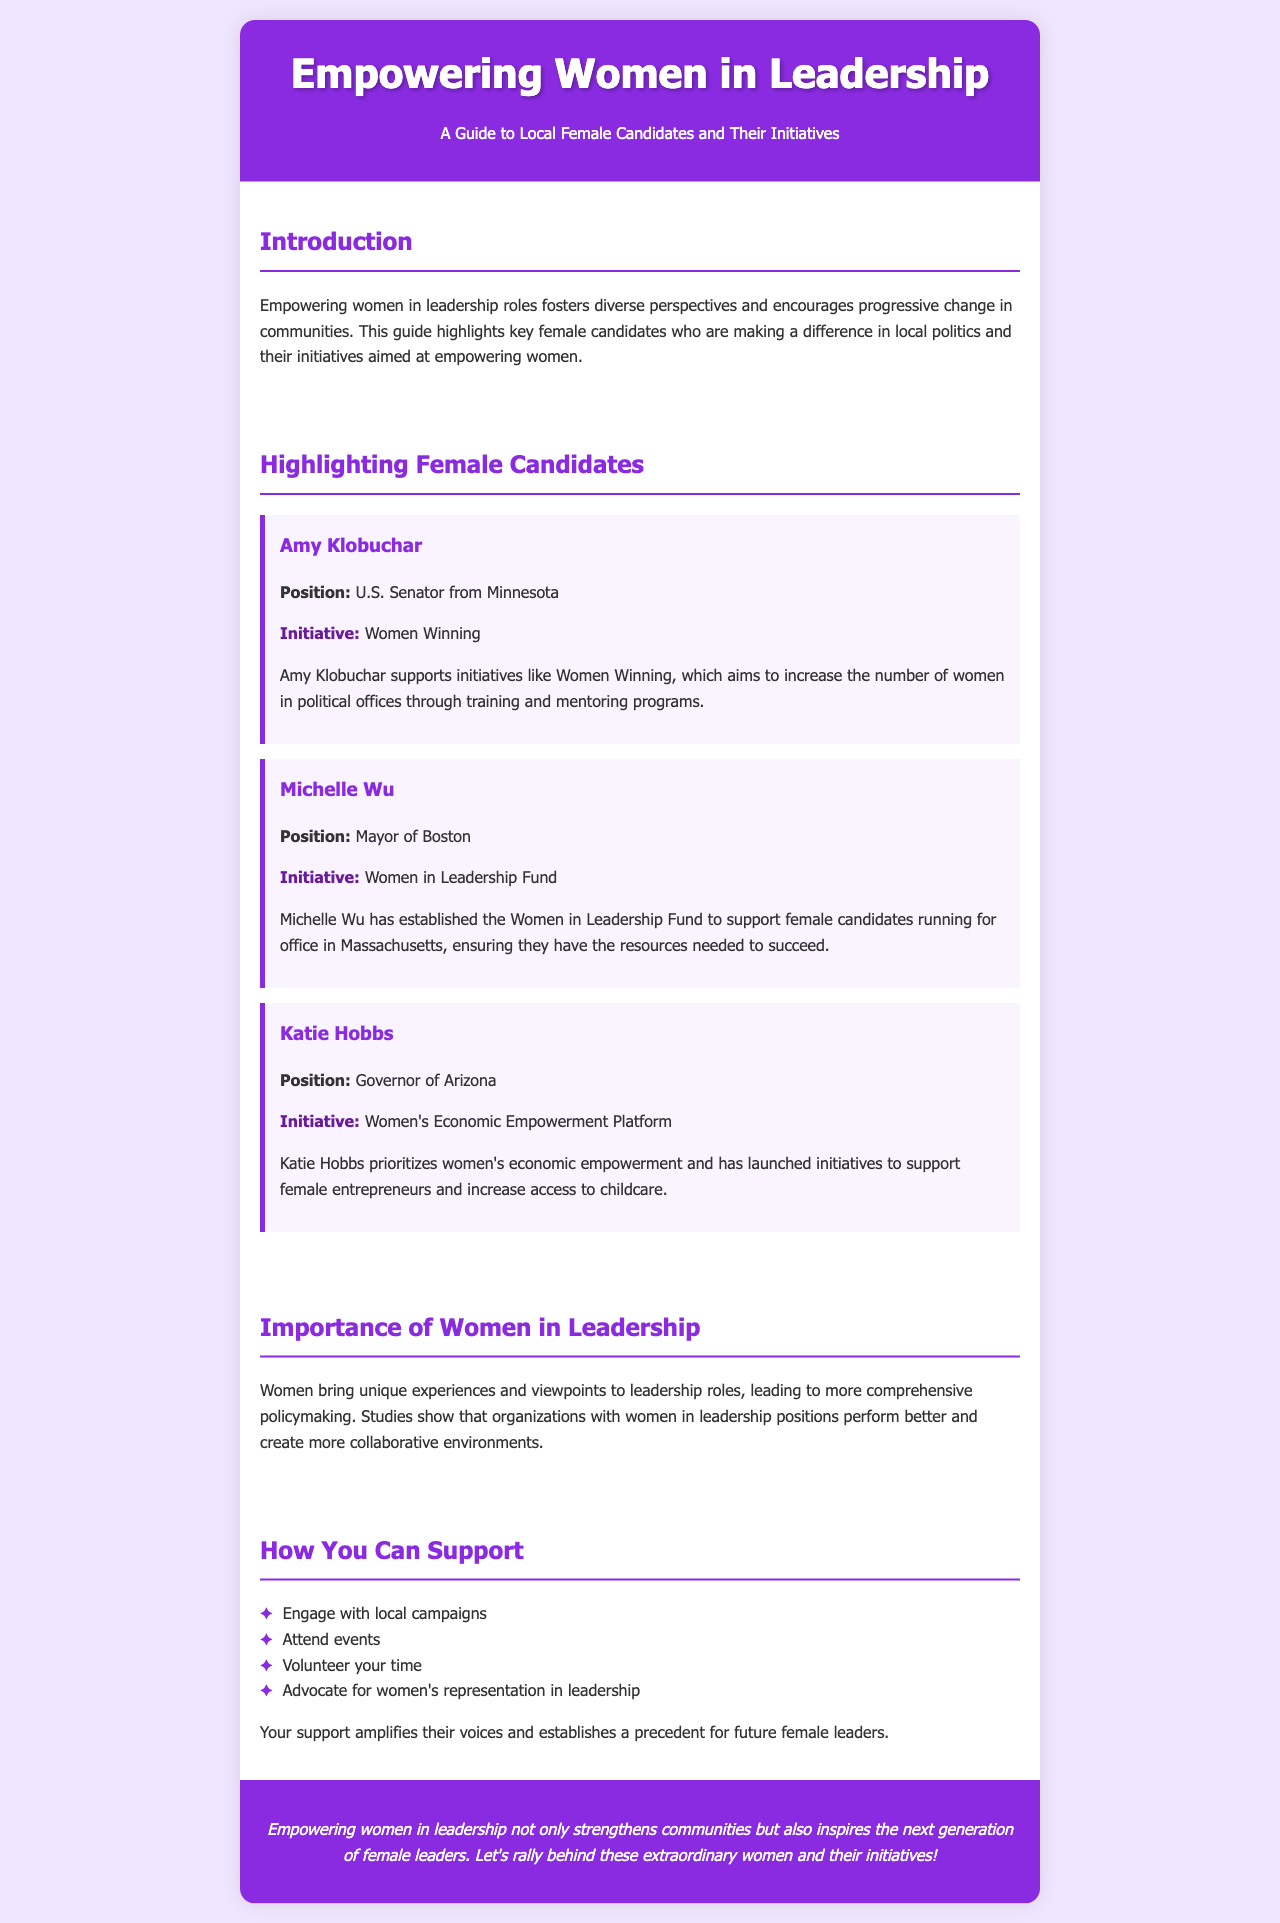What is the title of the brochure? The title of the brochure is prominently displayed at the top of the document.
Answer: Empowering Women in Leadership Who is the U.S. Senator from Minnesota? The document highlights female candidates, naming their positions.
Answer: Amy Klobuchar What initiative does Amy Klobuchar support? The document specifies what initiatives each candidate is involved in.
Answer: Women Winning What position does Michelle Wu hold? The document outlines the titles of the featured candidates.
Answer: Mayor of Boston What is Katie Hobbs' initiative focused on? The document describes the main focus of each candidate's initiatives.
Answer: Women's Economic Empowerment Platform How can you support female candidates? This information is covered in the "How You Can Support" section with a list.
Answer: Engage with local campaigns What is one benefit of having women in leadership? The document discusses the impact of women in leadership positions on organizations.
Answer: Better performance What color is used for the brochure's background? The background color of the brochure is mentioned in the styling section.
Answer: Light purple 